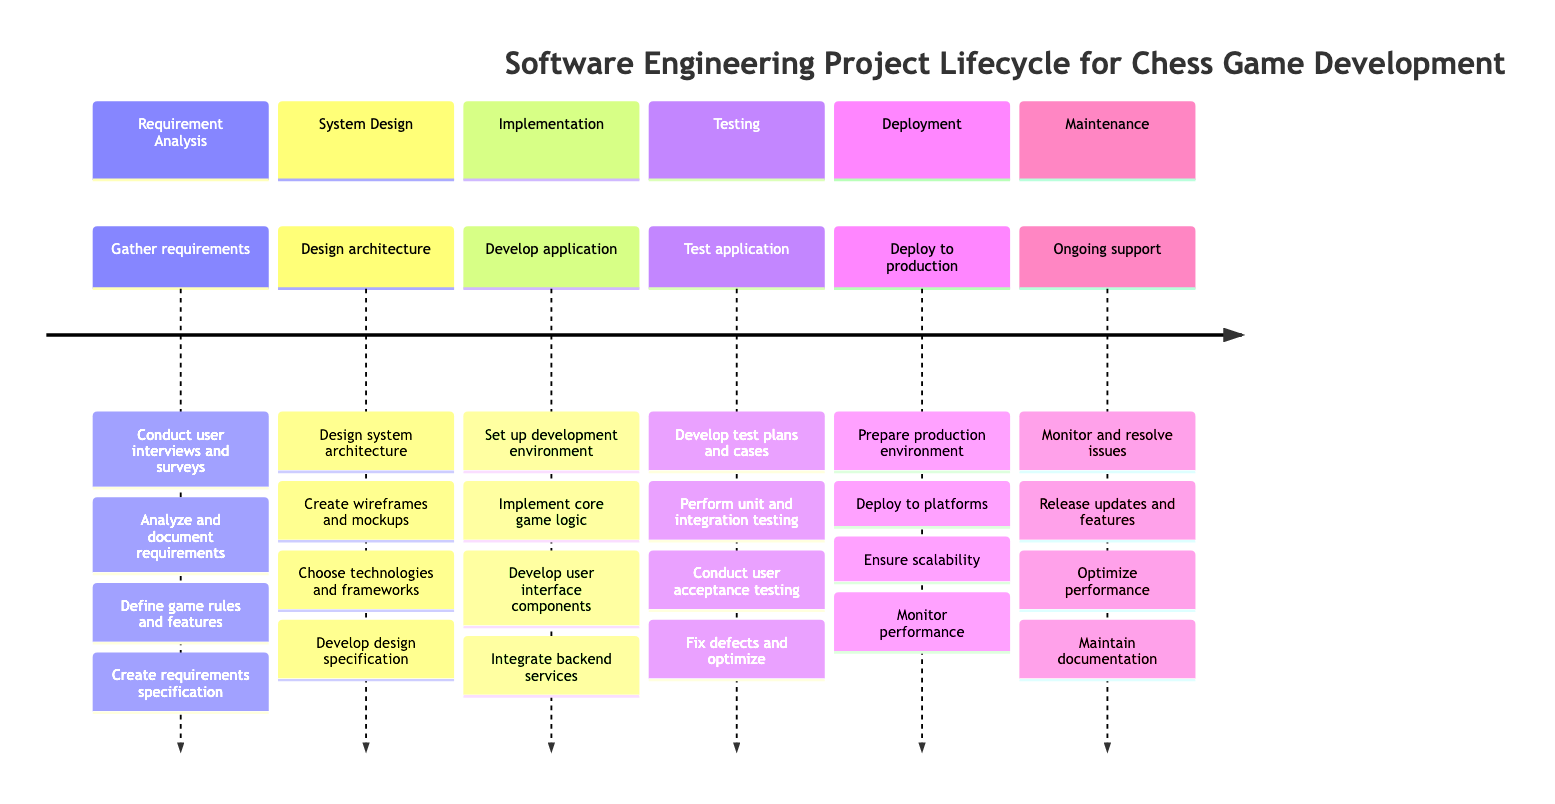What is the first phase of the project lifecycle? The diagram lists "Requirement Analysis" as the first section or phase.
Answer: Requirement Analysis How many phases are there in total? The diagram contains six distinct phases of the project lifecycle for the chess game application.
Answer: Six What task is associated with the "Testing" phase? The diagram includes specific tasks under the "Testing" phase such as "Develop test plans and test cases."
Answer: Develop test plans and test cases What is the last phase mentioned in the diagram? The final section of the timeline is "Maintenance," indicating that this is the last phase in the project lifecycle.
Answer: Maintenance Which phase involves "Deploy application to app stores or online platforms"? This task falls under the "Deployment" phase, which focuses on making the application accessible to users.
Answer: Deployment In which phase do you "Create wireframes and mockups"? The task of creating wireframes and mockups is listed under the "System Design" phase, emphasizing the design elements of the application.
Answer: System Design What is the primary focus of the "Implementation" phase? The main focus during the "Implementation" phase is to develop the chess game application based on design specifications, as outlined in the tasks.
Answer: Develop the chess game application What is one of the tasks in the "Maintenance" phase? One of the tasks in the "Maintenance" phase is to "Monitor and resolve issues reported by users," which involves ongoing support.
Answer: Monitor and resolve issues Which phase includes integrating with backend services? The task of integrating with backend services is part of the "Implementation" phase, highlighting its importance in development.
Answer: Implementation What is the task immediately after "Prepare production environment"? The next task following "Prepare production environment" is to "Deploy application to app stores or online platforms," indicating a sequence in the deployment process.
Answer: Deploy application to app stores or online platforms 